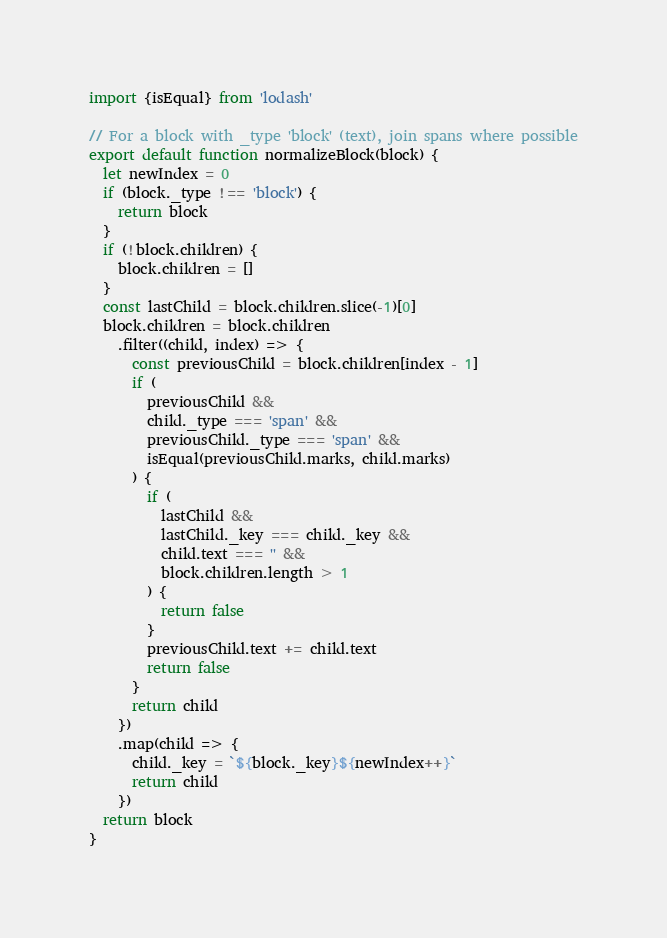Convert code to text. <code><loc_0><loc_0><loc_500><loc_500><_JavaScript_>import {isEqual} from 'lodash'

// For a block with _type 'block' (text), join spans where possible
export default function normalizeBlock(block) {
  let newIndex = 0
  if (block._type !== 'block') {
    return block
  }
  if (!block.children) {
    block.children = []
  }
  const lastChild = block.children.slice(-1)[0]
  block.children = block.children
    .filter((child, index) => {
      const previousChild = block.children[index - 1]
      if (
        previousChild &&
        child._type === 'span' &&
        previousChild._type === 'span' &&
        isEqual(previousChild.marks, child.marks)
      ) {
        if (
          lastChild &&
          lastChild._key === child._key &&
          child.text === '' &&
          block.children.length > 1
        ) {
          return false
        }
        previousChild.text += child.text
        return false
      }
      return child
    })
    .map(child => {
      child._key = `${block._key}${newIndex++}`
      return child
    })
  return block
}
</code> 